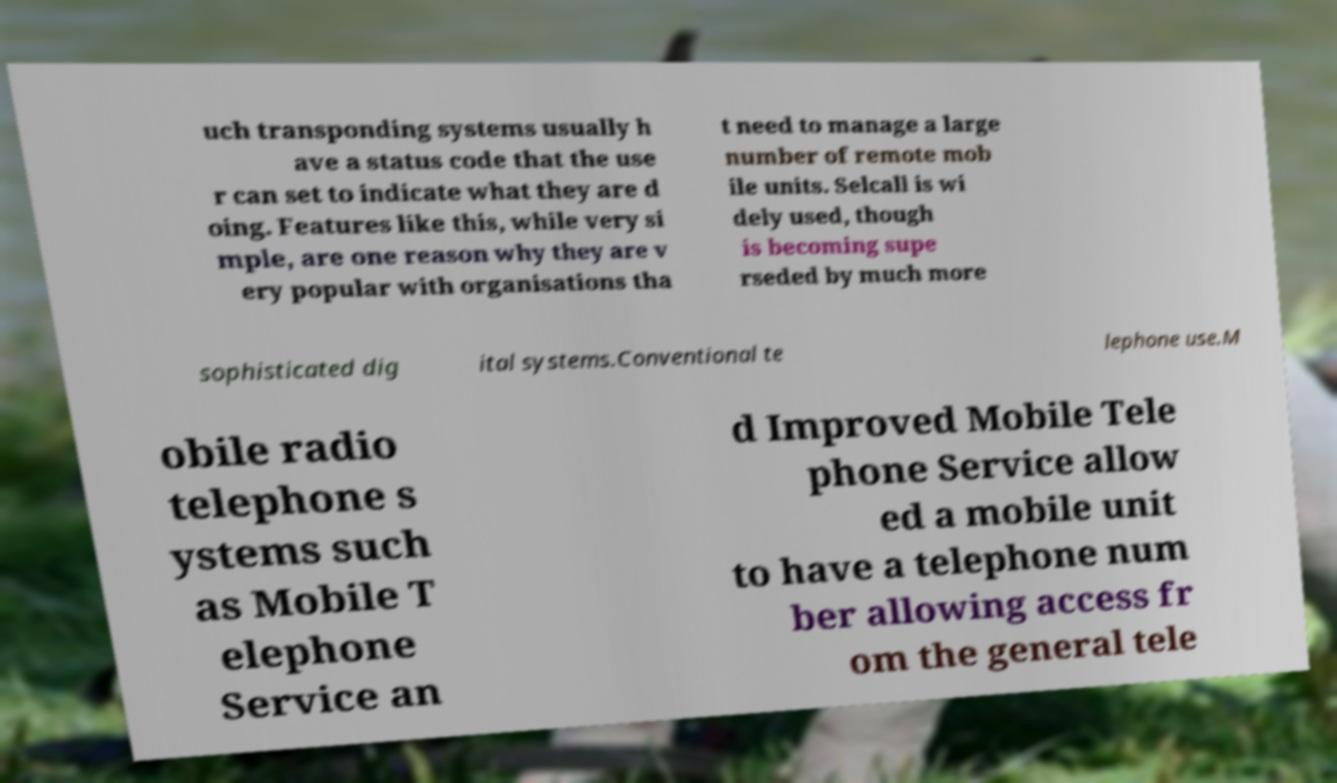Please read and relay the text visible in this image. What does it say? uch transponding systems usually h ave a status code that the use r can set to indicate what they are d oing. Features like this, while very si mple, are one reason why they are v ery popular with organisations tha t need to manage a large number of remote mob ile units. Selcall is wi dely used, though is becoming supe rseded by much more sophisticated dig ital systems.Conventional te lephone use.M obile radio telephone s ystems such as Mobile T elephone Service an d Improved Mobile Tele phone Service allow ed a mobile unit to have a telephone num ber allowing access fr om the general tele 